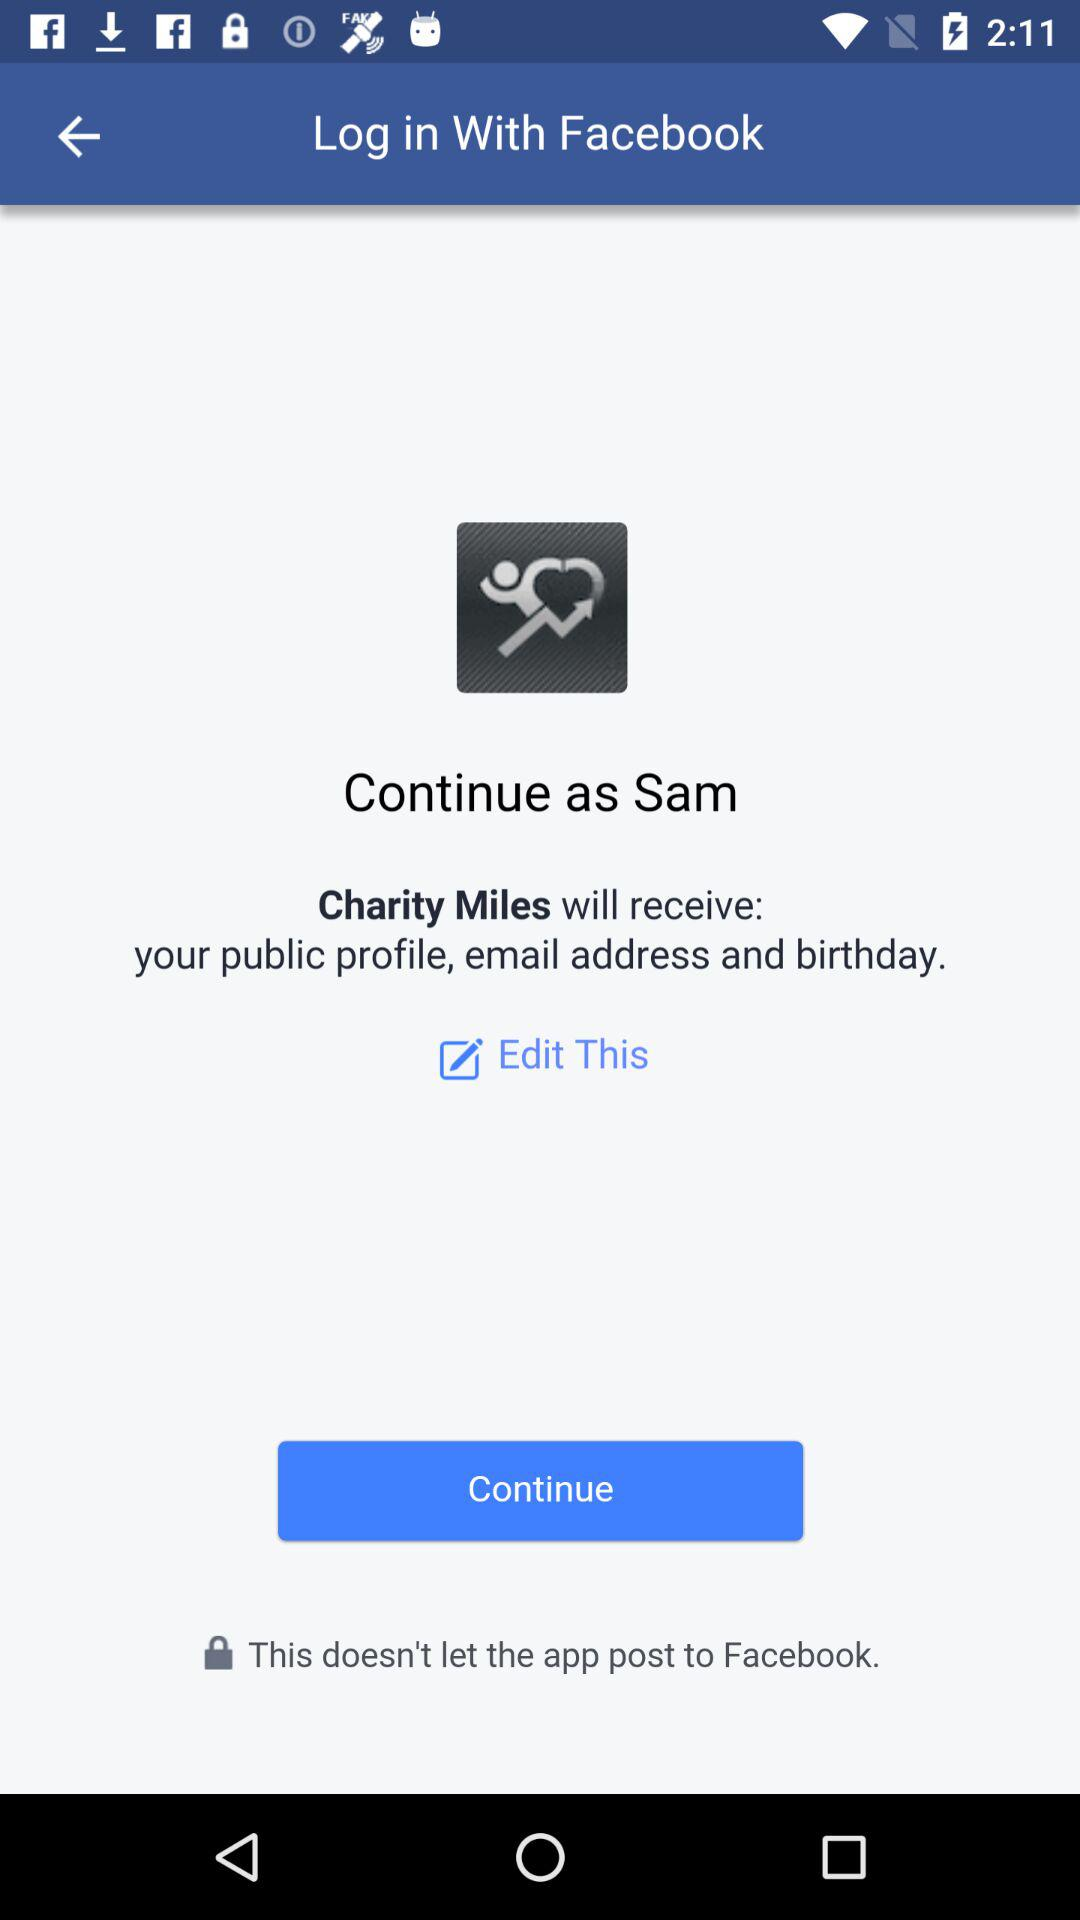Through what application is the person logging in? The person is logging in through "Facebook". 